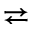<formula> <loc_0><loc_0><loc_500><loc_500>\right l e f t a r r o w s</formula> 